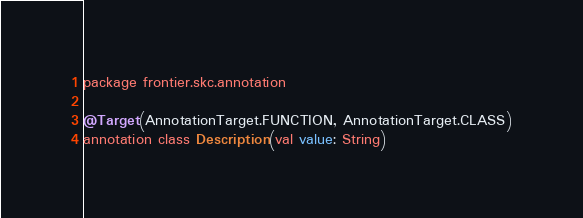Convert code to text. <code><loc_0><loc_0><loc_500><loc_500><_Kotlin_>package frontier.skc.annotation

@Target(AnnotationTarget.FUNCTION, AnnotationTarget.CLASS)
annotation class Description(val value: String)</code> 